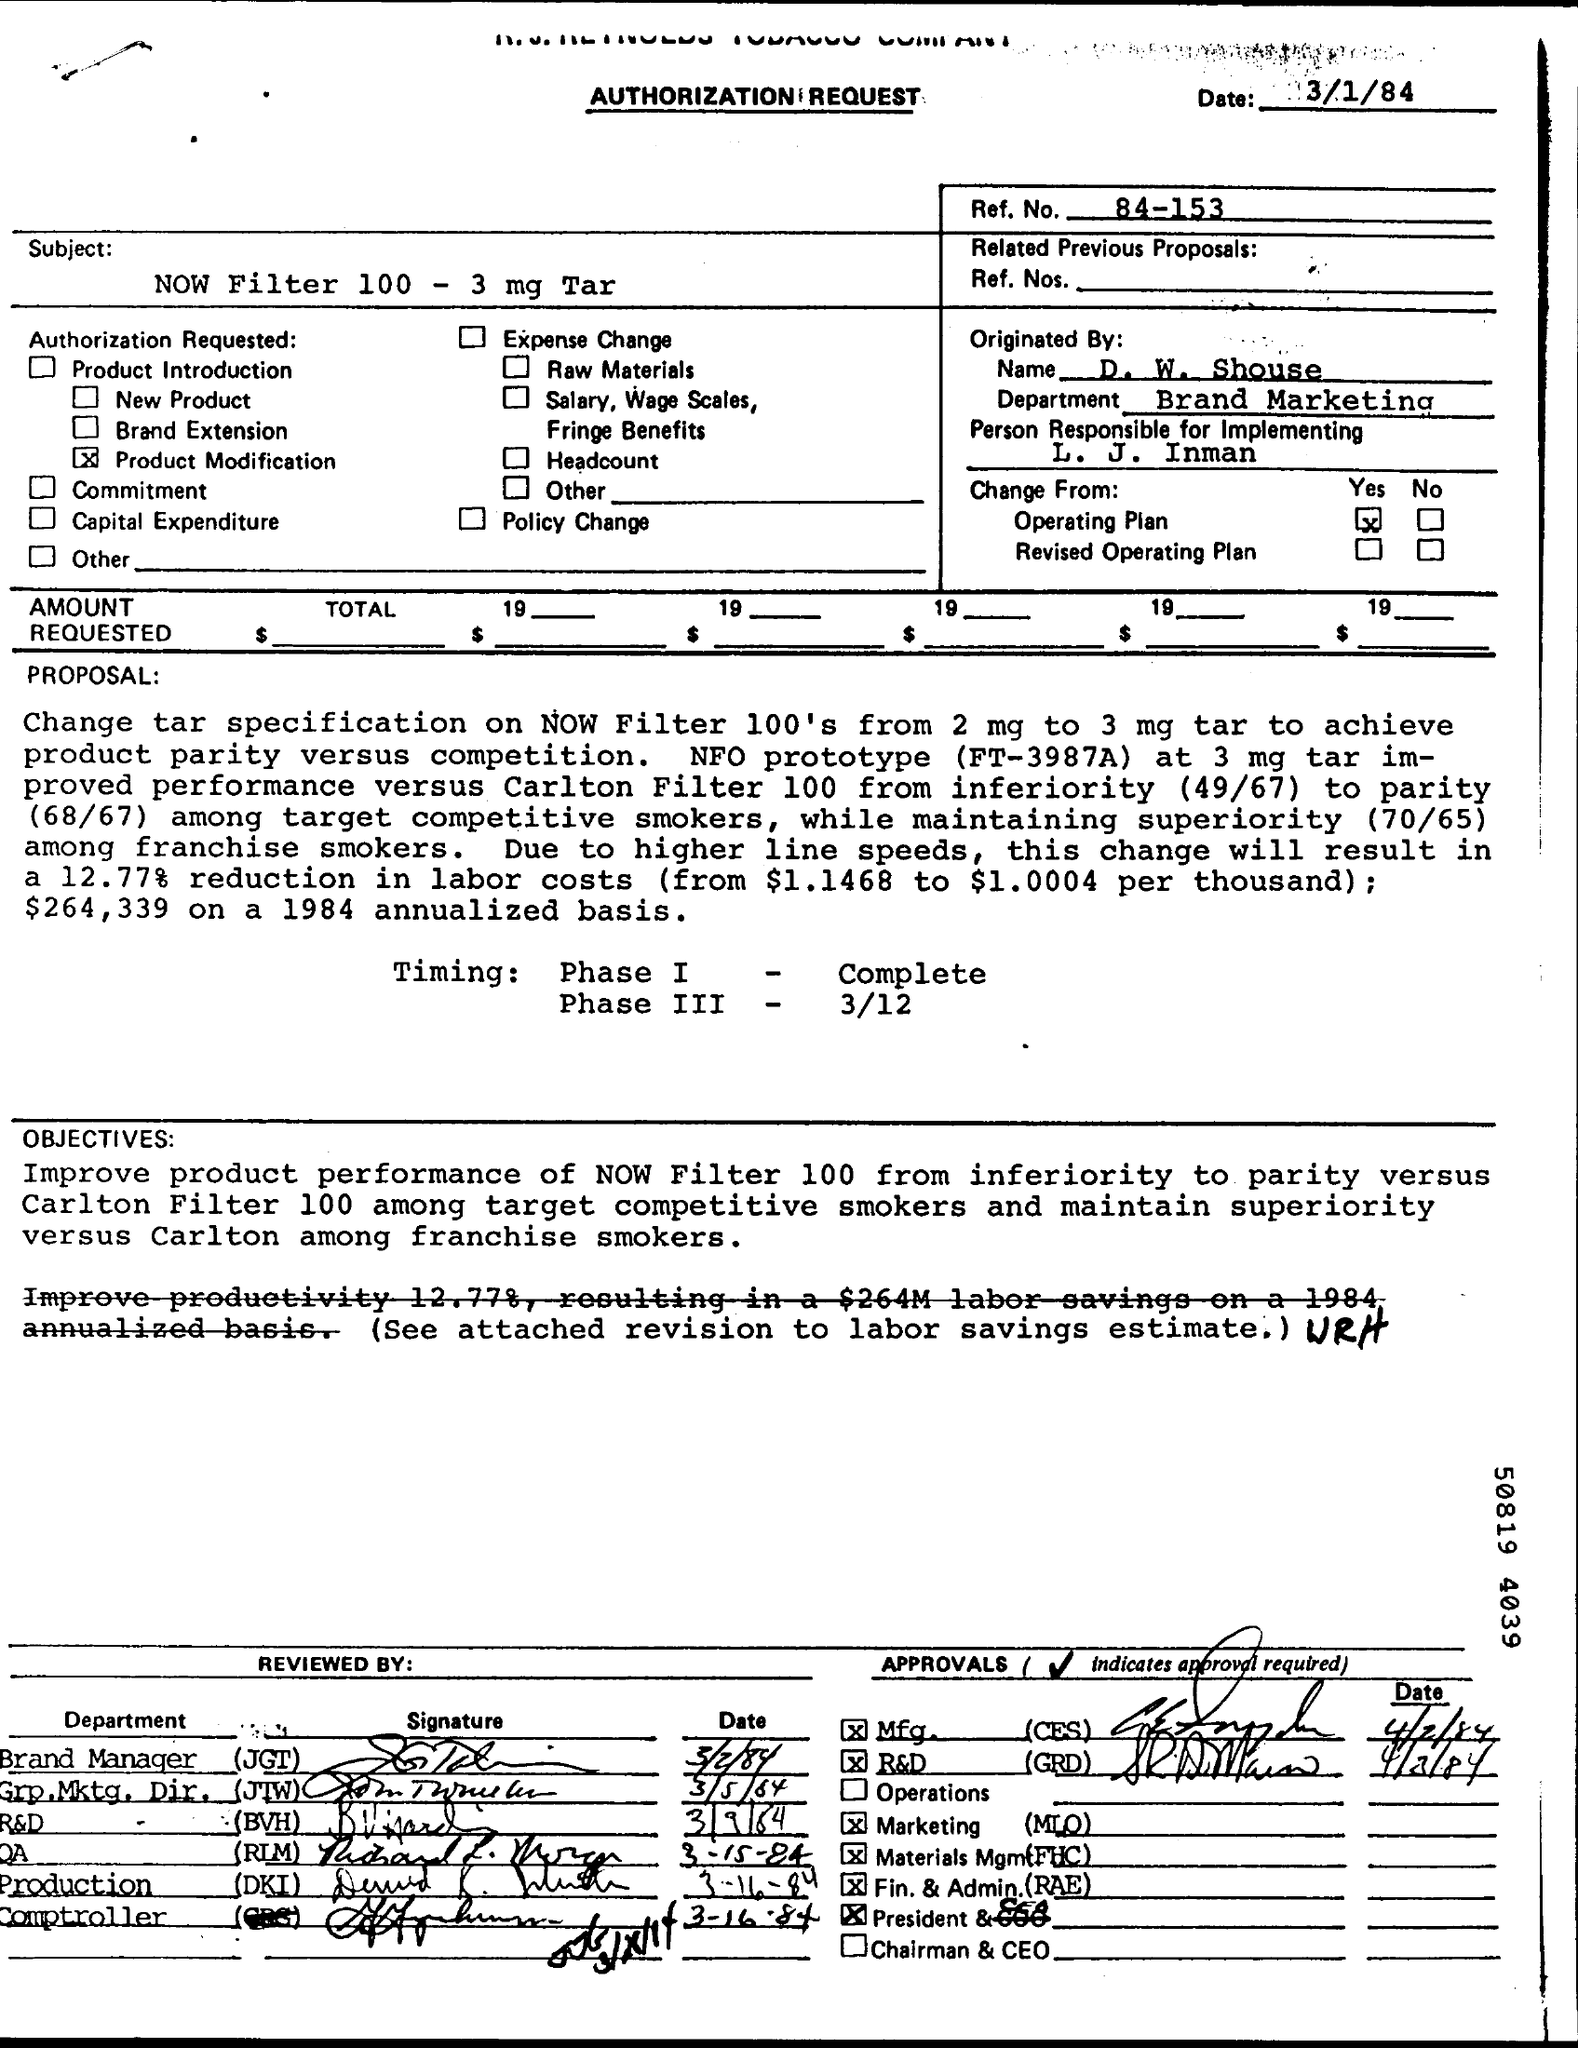Mention a couple of crucial points in this snapshot. The subject mentioned in the authorization request is a NOW filter with a tar level of 100 to 3 mg. The timing of Phase I has been completed. The timing of Phase III is 3/12. The issued date of this document is 3/1/84. The reference number mentioned in this document is 84-153.. 